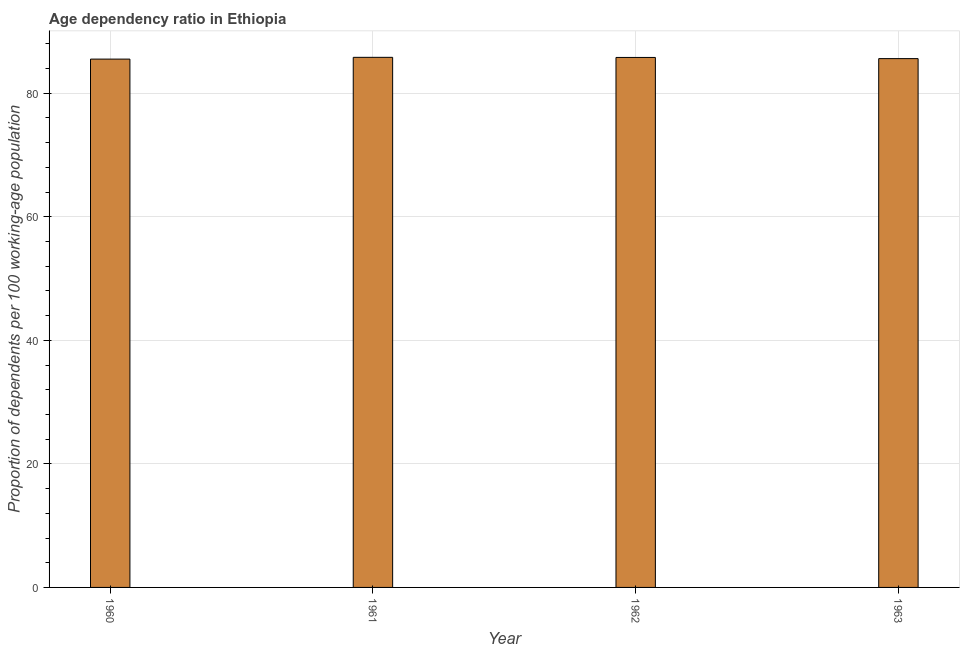What is the title of the graph?
Provide a short and direct response. Age dependency ratio in Ethiopia. What is the label or title of the Y-axis?
Provide a short and direct response. Proportion of dependents per 100 working-age population. What is the age dependency ratio in 1961?
Provide a succinct answer. 85.82. Across all years, what is the maximum age dependency ratio?
Give a very brief answer. 85.82. Across all years, what is the minimum age dependency ratio?
Your response must be concise. 85.53. In which year was the age dependency ratio maximum?
Provide a succinct answer. 1961. What is the sum of the age dependency ratio?
Make the answer very short. 342.75. What is the difference between the age dependency ratio in 1960 and 1961?
Keep it short and to the point. -0.29. What is the average age dependency ratio per year?
Your answer should be very brief. 85.69. What is the median age dependency ratio?
Make the answer very short. 85.7. What is the ratio of the age dependency ratio in 1960 to that in 1962?
Offer a terse response. 1. What is the difference between the highest and the second highest age dependency ratio?
Your response must be concise. 0.02. What is the difference between the highest and the lowest age dependency ratio?
Offer a terse response. 0.29. In how many years, is the age dependency ratio greater than the average age dependency ratio taken over all years?
Give a very brief answer. 2. How many years are there in the graph?
Provide a succinct answer. 4. What is the Proportion of dependents per 100 working-age population in 1960?
Your answer should be compact. 85.53. What is the Proportion of dependents per 100 working-age population of 1961?
Give a very brief answer. 85.82. What is the Proportion of dependents per 100 working-age population in 1962?
Provide a short and direct response. 85.8. What is the Proportion of dependents per 100 working-age population of 1963?
Give a very brief answer. 85.61. What is the difference between the Proportion of dependents per 100 working-age population in 1960 and 1961?
Offer a very short reply. -0.29. What is the difference between the Proportion of dependents per 100 working-age population in 1960 and 1962?
Offer a terse response. -0.27. What is the difference between the Proportion of dependents per 100 working-age population in 1960 and 1963?
Keep it short and to the point. -0.08. What is the difference between the Proportion of dependents per 100 working-age population in 1961 and 1962?
Offer a very short reply. 0.02. What is the difference between the Proportion of dependents per 100 working-age population in 1961 and 1963?
Your response must be concise. 0.21. What is the difference between the Proportion of dependents per 100 working-age population in 1962 and 1963?
Keep it short and to the point. 0.19. What is the ratio of the Proportion of dependents per 100 working-age population in 1960 to that in 1961?
Give a very brief answer. 1. What is the ratio of the Proportion of dependents per 100 working-age population in 1960 to that in 1962?
Make the answer very short. 1. What is the ratio of the Proportion of dependents per 100 working-age population in 1960 to that in 1963?
Your answer should be compact. 1. What is the ratio of the Proportion of dependents per 100 working-age population in 1961 to that in 1962?
Provide a succinct answer. 1. What is the ratio of the Proportion of dependents per 100 working-age population in 1961 to that in 1963?
Offer a very short reply. 1. 